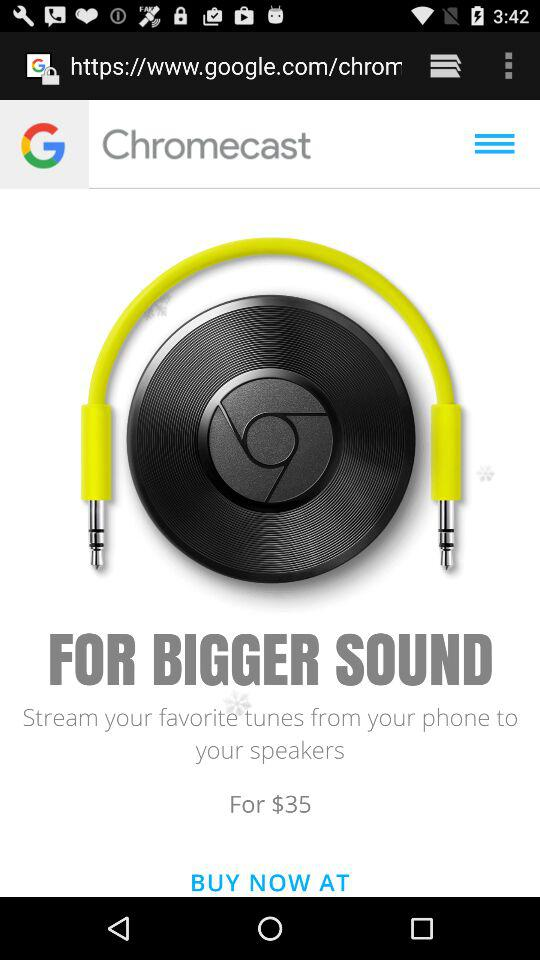What is the price of the speaker? The price of the speaker is $35. 